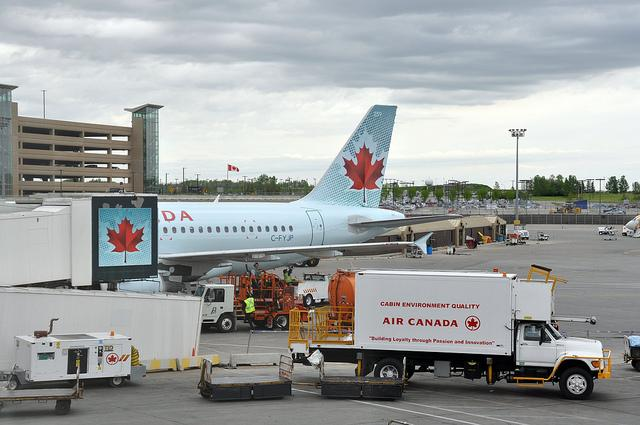What continent is this country located at? Please explain your reasoning. north america. The country is in north america since it's canada. 